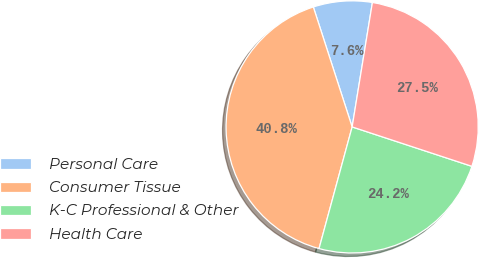Convert chart. <chart><loc_0><loc_0><loc_500><loc_500><pie_chart><fcel>Personal Care<fcel>Consumer Tissue<fcel>K-C Professional & Other<fcel>Health Care<nl><fcel>7.55%<fcel>40.79%<fcel>24.17%<fcel>27.49%<nl></chart> 